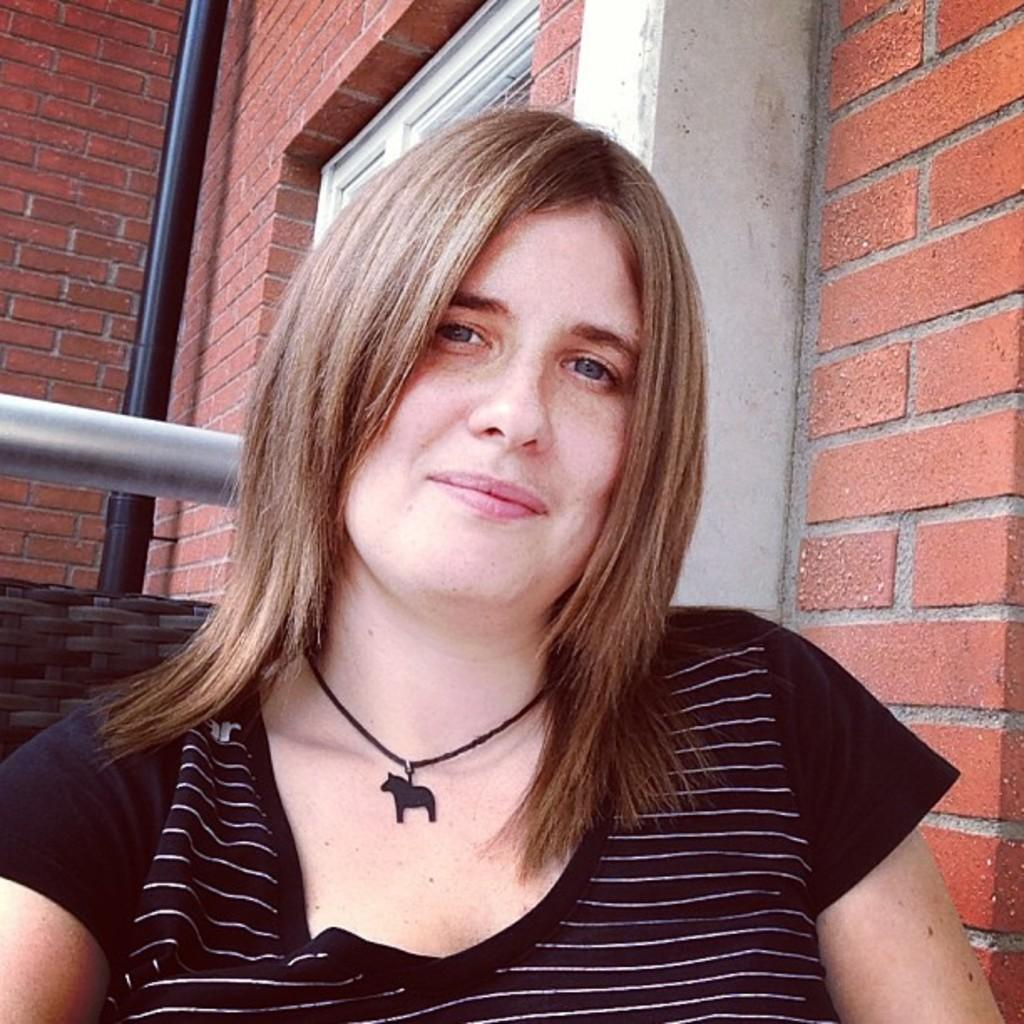What is the main subject of the image? There is a woman in the image. What is the woman doing in the image? The woman is watching and smiling. What can be seen in the background of the image? There is a rod, a pole, a brick wall, and a window in the background of the image. What type of skirt is the woman wearing in the image? There is no information about the woman's clothing in the image, so we cannot determine if she is wearing a skirt or not. 